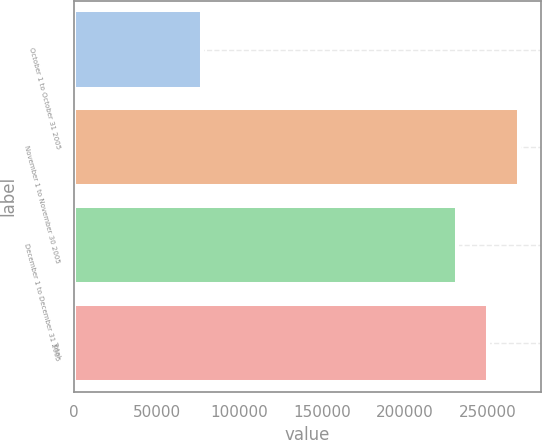Convert chart. <chart><loc_0><loc_0><loc_500><loc_500><bar_chart><fcel>October 1 to October 31 2005<fcel>November 1 to November 30 2005<fcel>December 1 to December 31 2005<fcel>Total<nl><fcel>77585<fcel>268595<fcel>231619<fcel>250107<nl></chart> 